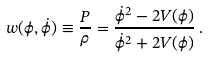Convert formula to latex. <formula><loc_0><loc_0><loc_500><loc_500>w ( \phi , \dot { \phi } ) \equiv \frac { P } { \rho } = \frac { \dot { \phi } ^ { 2 } - 2 V ( \phi ) } { \dot { \phi } ^ { 2 } + 2 V ( \phi ) } \, .</formula> 